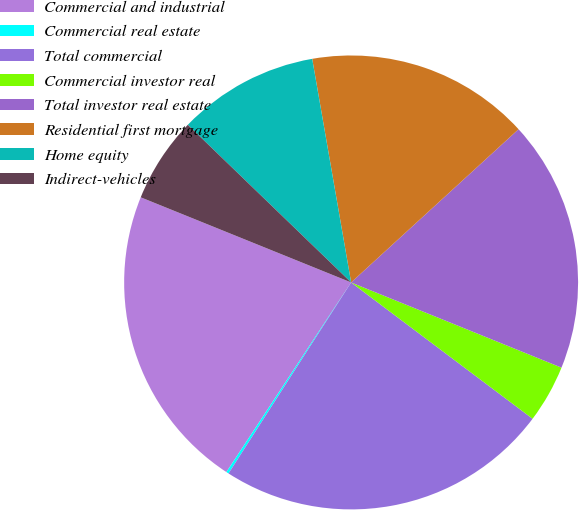<chart> <loc_0><loc_0><loc_500><loc_500><pie_chart><fcel>Commercial and industrial<fcel>Commercial real estate<fcel>Total commercial<fcel>Commercial investor real<fcel>Total investor real estate<fcel>Residential first mortgage<fcel>Home equity<fcel>Indirect-vehicles<nl><fcel>21.86%<fcel>0.18%<fcel>23.83%<fcel>4.13%<fcel>17.92%<fcel>15.95%<fcel>10.04%<fcel>6.1%<nl></chart> 